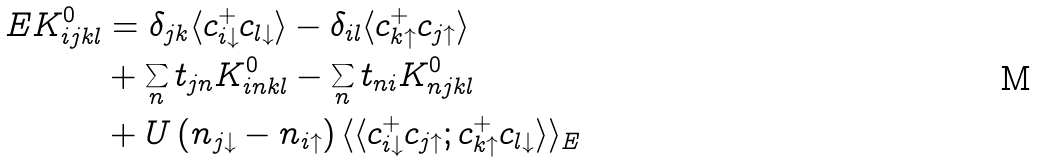Convert formula to latex. <formula><loc_0><loc_0><loc_500><loc_500>E K ^ { 0 } _ { i j k l } & = \delta _ { j k } \langle c ^ { + } _ { i \downarrow } c _ { l \downarrow } \rangle - \delta _ { i l } \langle c ^ { + } _ { k \uparrow } c _ { j \uparrow } \rangle \\ & + \sum _ { n } t _ { j n } K ^ { 0 } _ { i n k l } - \sum _ { n } t _ { n i } K ^ { 0 } _ { n j k l } \\ & + U \left ( n _ { j \downarrow } - n _ { i \uparrow } \right ) \langle \langle c ^ { + } _ { i \downarrow } c _ { j \uparrow } ; c ^ { + } _ { k \uparrow } c _ { l \downarrow } \rangle \rangle _ { E }</formula> 